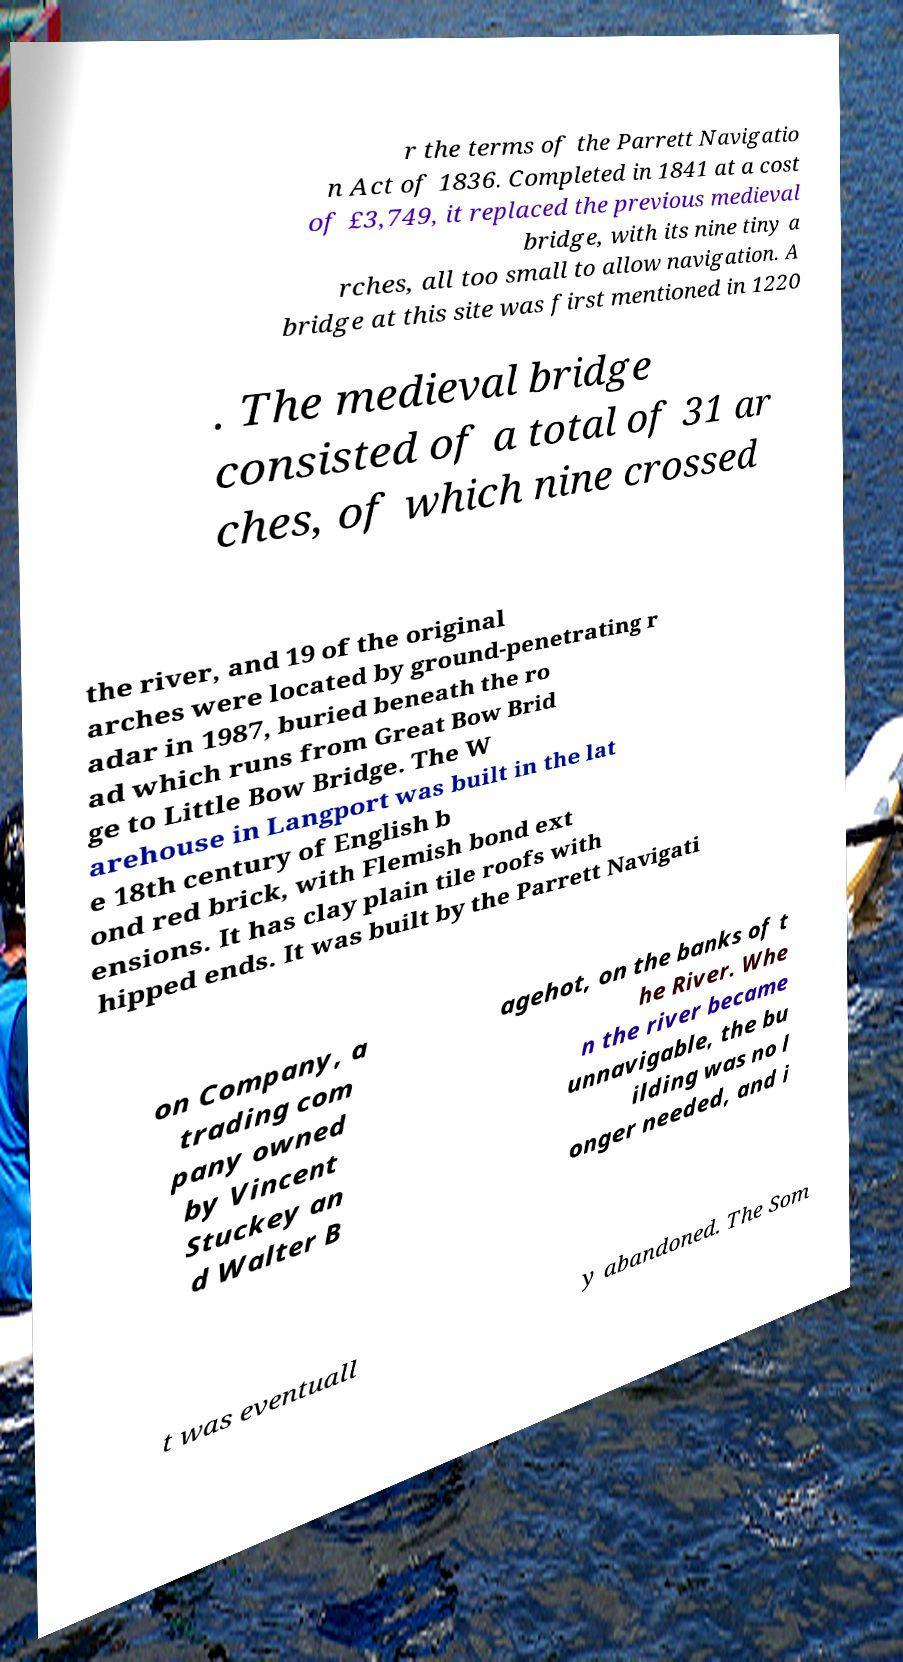For documentation purposes, I need the text within this image transcribed. Could you provide that? r the terms of the Parrett Navigatio n Act of 1836. Completed in 1841 at a cost of £3,749, it replaced the previous medieval bridge, with its nine tiny a rches, all too small to allow navigation. A bridge at this site was first mentioned in 1220 . The medieval bridge consisted of a total of 31 ar ches, of which nine crossed the river, and 19 of the original arches were located by ground-penetrating r adar in 1987, buried beneath the ro ad which runs from Great Bow Brid ge to Little Bow Bridge. The W arehouse in Langport was built in the lat e 18th century of English b ond red brick, with Flemish bond ext ensions. It has clay plain tile roofs with hipped ends. It was built by the Parrett Navigati on Company, a trading com pany owned by Vincent Stuckey an d Walter B agehot, on the banks of t he River. Whe n the river became unnavigable, the bu ilding was no l onger needed, and i t was eventuall y abandoned. The Som 